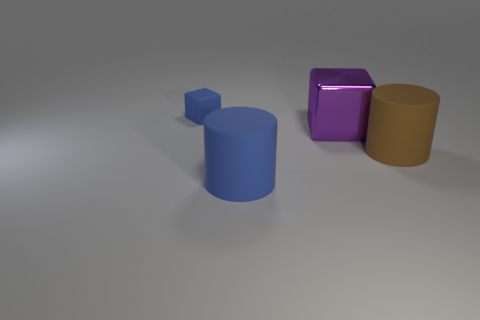There is a cube on the right side of the thing behind the big metallic cube; what is its size?
Your response must be concise. Large. Are there any other things that are the same shape as the large metal object?
Offer a terse response. Yes. Is the number of big shiny things less than the number of gray rubber cubes?
Your answer should be very brief. No. The thing that is both left of the large block and in front of the tiny blue matte block is made of what material?
Provide a short and direct response. Rubber. There is a rubber cylinder that is behind the large blue cylinder; are there any brown rubber cylinders in front of it?
Provide a short and direct response. No. How many objects are either cyan objects or big brown rubber objects?
Your answer should be compact. 1. What is the shape of the matte thing that is behind the big blue cylinder and left of the brown matte thing?
Keep it short and to the point. Cube. Is the material of the cylinder that is in front of the brown rubber thing the same as the purple thing?
Ensure brevity in your answer.  No. How many things are either large cylinders or blue rubber objects that are to the right of the small blue thing?
Your response must be concise. 2. What color is the cube that is the same material as the large brown thing?
Provide a succinct answer. Blue. 